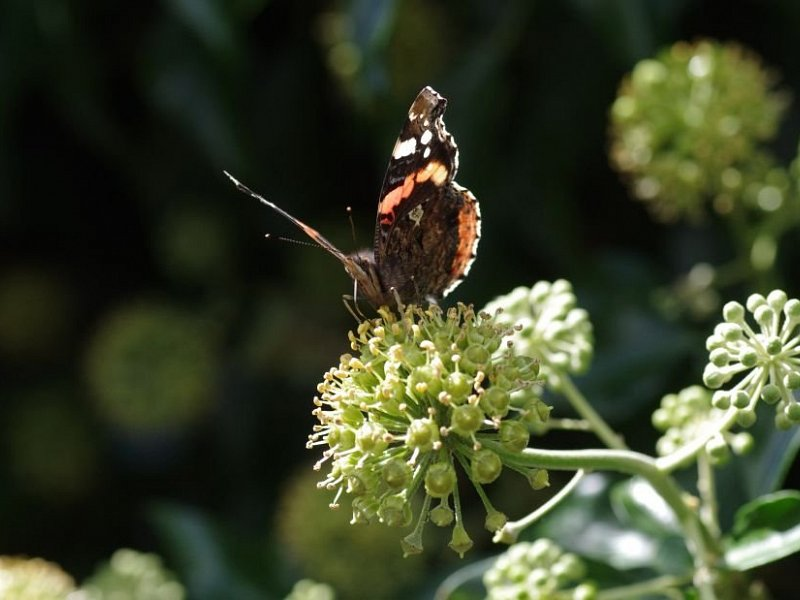If this scene had a soundtrack, what would it sound like? If this scene had a soundtrack, it would be a harmonious blend of nature's symphony. The music of the garden would include the gentle hum of bees as they pollinate flowers, the soft rustling of leaves in the background, and the occasional chirping of birds. There might be the subtle fluttering sound of the butterfly's wings as it moves between flowers, accompanied by a light breeze that swirls around the garden. This peaceful and rhythmic soundtrack would perfectly complement the serene and vibrant visual of the butterfly feeding on the blooming plant. How might the changing seasons alter this soundtrack? As seasons change, the garden's soundtrack evolves. In spring, the garden would be alive with the songs of returning migratory birds and the buzzing of newly awakened bees. Soft rains might add a gentle patter to the background. Summer's heat would amplify the sounds of more active insects and lush foliage. Autumn might bring the rustling of drying leaves and the occasional call of migrating birds. In winter, the garden would grow quieter, with sounds of wind through bare branches and the occasional chirp from hardy birds or the crunch of snow underfoot, giving the garden a more tranquil and hushed ambiance. 